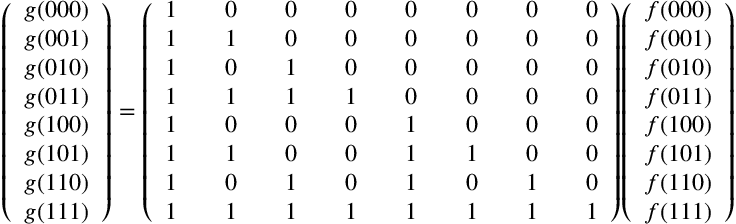Convert formula to latex. <formula><loc_0><loc_0><loc_500><loc_500>{ \left ( \begin{array} { l } { g ( 0 0 0 ) } \\ { g ( 0 0 1 ) } \\ { g ( 0 1 0 ) } \\ { g ( 0 1 1 ) } \\ { g ( 1 0 0 ) } \\ { g ( 1 0 1 ) } \\ { g ( 1 1 0 ) } \\ { g ( 1 1 1 ) } \end{array} \right ) } = { \left ( \begin{array} { l l l l l l l l l l l l l l l } { 1 } & & { 0 } & & { 0 } & & { 0 } & & { 0 } & & { 0 } & & { 0 } & & { 0 } \\ { 1 } & & { 1 } & & { 0 } & & { 0 } & & { 0 } & & { 0 } & & { 0 } & & { 0 } \\ { 1 } & & { 0 } & & { 1 } & & { 0 } & & { 0 } & & { 0 } & & { 0 } & & { 0 } \\ { 1 } & & { 1 } & & { 1 } & & { 1 } & & { 0 } & & { 0 } & & { 0 } & & { 0 } \\ { 1 } & & { 0 } & & { 0 } & & { 0 } & & { 1 } & & { 0 } & & { 0 } & & { 0 } \\ { 1 } & & { 1 } & & { 0 } & & { 0 } & & { 1 } & & { 1 } & & { 0 } & & { 0 } \\ { 1 } & & { 0 } & & { 1 } & & { 0 } & & { 1 } & & { 0 } & & { 1 } & & { 0 } \\ { 1 } & & { 1 } & & { 1 } & & { 1 } & & { 1 } & & { 1 } & & { 1 } & & { 1 } \end{array} \right ) } { \left ( \begin{array} { l } { f ( 0 0 0 ) } \\ { f ( 0 0 1 ) } \\ { f ( 0 1 0 ) } \\ { f ( 0 1 1 ) } \\ { f ( 1 0 0 ) } \\ { f ( 1 0 1 ) } \\ { f ( 1 1 0 ) } \\ { f ( 1 1 1 ) } \end{array} \right ) }</formula> 